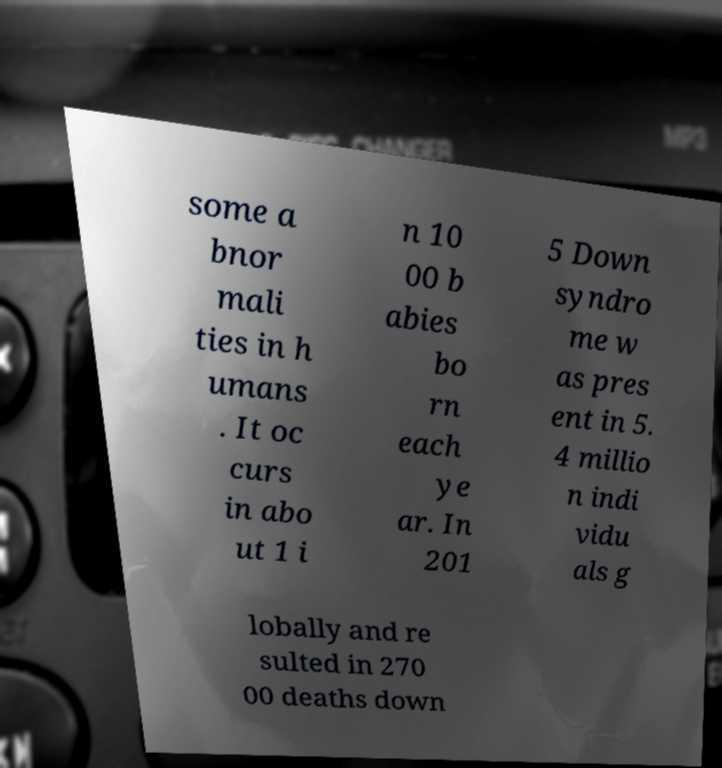For documentation purposes, I need the text within this image transcribed. Could you provide that? some a bnor mali ties in h umans . It oc curs in abo ut 1 i n 10 00 b abies bo rn each ye ar. In 201 5 Down syndro me w as pres ent in 5. 4 millio n indi vidu als g lobally and re sulted in 270 00 deaths down 